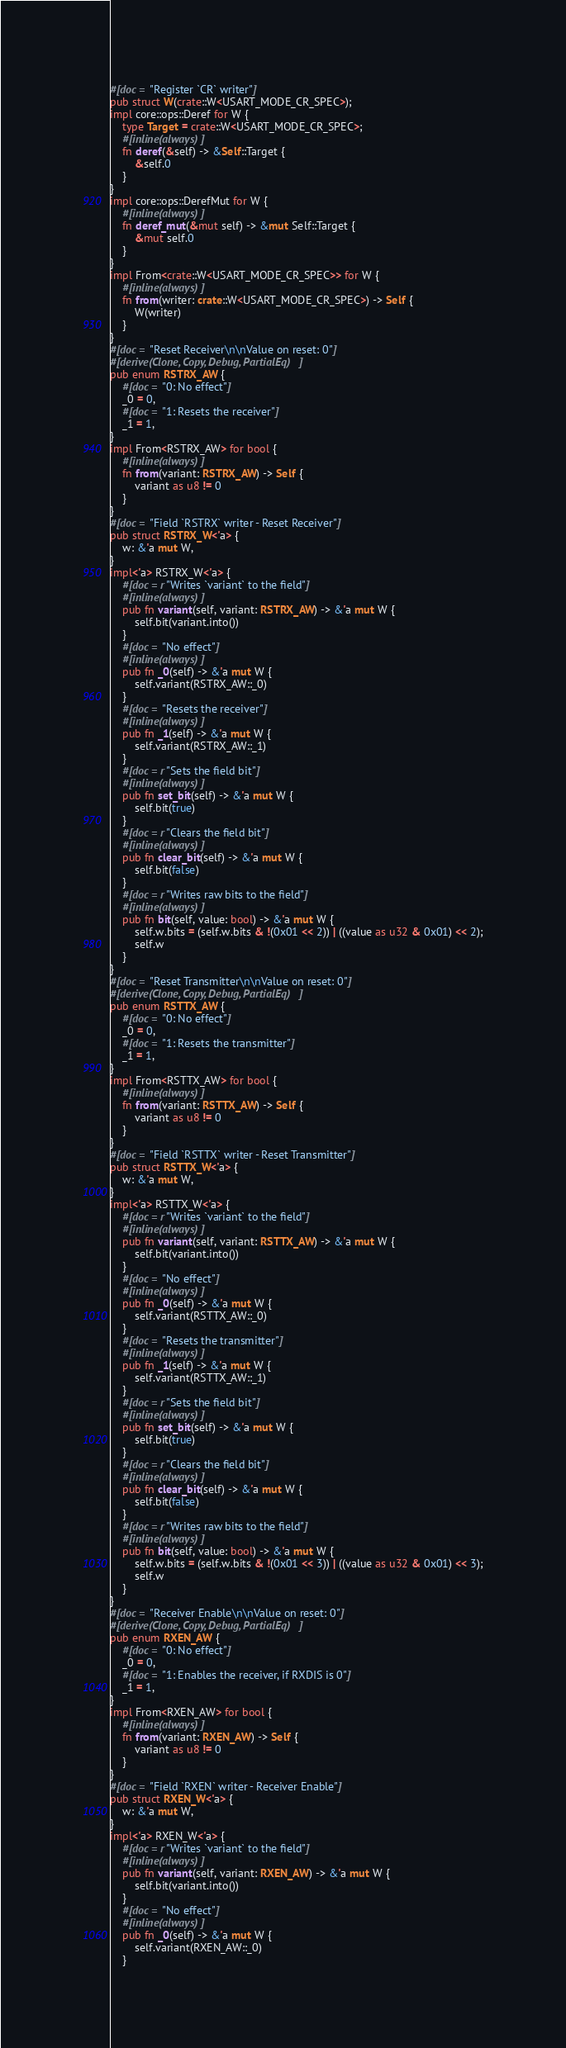<code> <loc_0><loc_0><loc_500><loc_500><_Rust_>#[doc = "Register `CR` writer"]
pub struct W(crate::W<USART_MODE_CR_SPEC>);
impl core::ops::Deref for W {
    type Target = crate::W<USART_MODE_CR_SPEC>;
    #[inline(always)]
    fn deref(&self) -> &Self::Target {
        &self.0
    }
}
impl core::ops::DerefMut for W {
    #[inline(always)]
    fn deref_mut(&mut self) -> &mut Self::Target {
        &mut self.0
    }
}
impl From<crate::W<USART_MODE_CR_SPEC>> for W {
    #[inline(always)]
    fn from(writer: crate::W<USART_MODE_CR_SPEC>) -> Self {
        W(writer)
    }
}
#[doc = "Reset Receiver\n\nValue on reset: 0"]
#[derive(Clone, Copy, Debug, PartialEq)]
pub enum RSTRX_AW {
    #[doc = "0: No effect"]
    _0 = 0,
    #[doc = "1: Resets the receiver"]
    _1 = 1,
}
impl From<RSTRX_AW> for bool {
    #[inline(always)]
    fn from(variant: RSTRX_AW) -> Self {
        variant as u8 != 0
    }
}
#[doc = "Field `RSTRX` writer - Reset Receiver"]
pub struct RSTRX_W<'a> {
    w: &'a mut W,
}
impl<'a> RSTRX_W<'a> {
    #[doc = r"Writes `variant` to the field"]
    #[inline(always)]
    pub fn variant(self, variant: RSTRX_AW) -> &'a mut W {
        self.bit(variant.into())
    }
    #[doc = "No effect"]
    #[inline(always)]
    pub fn _0(self) -> &'a mut W {
        self.variant(RSTRX_AW::_0)
    }
    #[doc = "Resets the receiver"]
    #[inline(always)]
    pub fn _1(self) -> &'a mut W {
        self.variant(RSTRX_AW::_1)
    }
    #[doc = r"Sets the field bit"]
    #[inline(always)]
    pub fn set_bit(self) -> &'a mut W {
        self.bit(true)
    }
    #[doc = r"Clears the field bit"]
    #[inline(always)]
    pub fn clear_bit(self) -> &'a mut W {
        self.bit(false)
    }
    #[doc = r"Writes raw bits to the field"]
    #[inline(always)]
    pub fn bit(self, value: bool) -> &'a mut W {
        self.w.bits = (self.w.bits & !(0x01 << 2)) | ((value as u32 & 0x01) << 2);
        self.w
    }
}
#[doc = "Reset Transmitter\n\nValue on reset: 0"]
#[derive(Clone, Copy, Debug, PartialEq)]
pub enum RSTTX_AW {
    #[doc = "0: No effect"]
    _0 = 0,
    #[doc = "1: Resets the transmitter"]
    _1 = 1,
}
impl From<RSTTX_AW> for bool {
    #[inline(always)]
    fn from(variant: RSTTX_AW) -> Self {
        variant as u8 != 0
    }
}
#[doc = "Field `RSTTX` writer - Reset Transmitter"]
pub struct RSTTX_W<'a> {
    w: &'a mut W,
}
impl<'a> RSTTX_W<'a> {
    #[doc = r"Writes `variant` to the field"]
    #[inline(always)]
    pub fn variant(self, variant: RSTTX_AW) -> &'a mut W {
        self.bit(variant.into())
    }
    #[doc = "No effect"]
    #[inline(always)]
    pub fn _0(self) -> &'a mut W {
        self.variant(RSTTX_AW::_0)
    }
    #[doc = "Resets the transmitter"]
    #[inline(always)]
    pub fn _1(self) -> &'a mut W {
        self.variant(RSTTX_AW::_1)
    }
    #[doc = r"Sets the field bit"]
    #[inline(always)]
    pub fn set_bit(self) -> &'a mut W {
        self.bit(true)
    }
    #[doc = r"Clears the field bit"]
    #[inline(always)]
    pub fn clear_bit(self) -> &'a mut W {
        self.bit(false)
    }
    #[doc = r"Writes raw bits to the field"]
    #[inline(always)]
    pub fn bit(self, value: bool) -> &'a mut W {
        self.w.bits = (self.w.bits & !(0x01 << 3)) | ((value as u32 & 0x01) << 3);
        self.w
    }
}
#[doc = "Receiver Enable\n\nValue on reset: 0"]
#[derive(Clone, Copy, Debug, PartialEq)]
pub enum RXEN_AW {
    #[doc = "0: No effect"]
    _0 = 0,
    #[doc = "1: Enables the receiver, if RXDIS is 0"]
    _1 = 1,
}
impl From<RXEN_AW> for bool {
    #[inline(always)]
    fn from(variant: RXEN_AW) -> Self {
        variant as u8 != 0
    }
}
#[doc = "Field `RXEN` writer - Receiver Enable"]
pub struct RXEN_W<'a> {
    w: &'a mut W,
}
impl<'a> RXEN_W<'a> {
    #[doc = r"Writes `variant` to the field"]
    #[inline(always)]
    pub fn variant(self, variant: RXEN_AW) -> &'a mut W {
        self.bit(variant.into())
    }
    #[doc = "No effect"]
    #[inline(always)]
    pub fn _0(self) -> &'a mut W {
        self.variant(RXEN_AW::_0)
    }</code> 